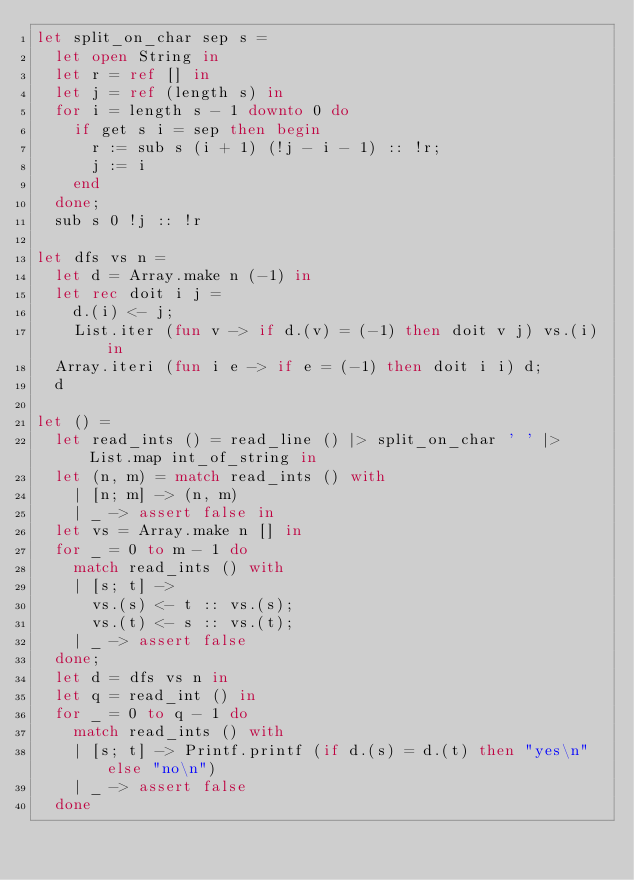Convert code to text. <code><loc_0><loc_0><loc_500><loc_500><_OCaml_>let split_on_char sep s =
  let open String in
  let r = ref [] in
  let j = ref (length s) in
  for i = length s - 1 downto 0 do
    if get s i = sep then begin
      r := sub s (i + 1) (!j - i - 1) :: !r;
      j := i
    end
  done;
  sub s 0 !j :: !r

let dfs vs n =
  let d = Array.make n (-1) in
  let rec doit i j =
    d.(i) <- j;
    List.iter (fun v -> if d.(v) = (-1) then doit v j) vs.(i) in
  Array.iteri (fun i e -> if e = (-1) then doit i i) d;
  d

let () =
  let read_ints () = read_line () |> split_on_char ' ' |>  List.map int_of_string in
  let (n, m) = match read_ints () with
    | [n; m] -> (n, m)
    | _ -> assert false in
  let vs = Array.make n [] in
  for _ = 0 to m - 1 do
    match read_ints () with
    | [s; t] ->
      vs.(s) <- t :: vs.(s);
      vs.(t) <- s :: vs.(t);
    | _ -> assert false
  done;
  let d = dfs vs n in
  let q = read_int () in
  for _ = 0 to q - 1 do
    match read_ints () with
    | [s; t] -> Printf.printf (if d.(s) = d.(t) then "yes\n" else "no\n")
    | _ -> assert false
  done</code> 